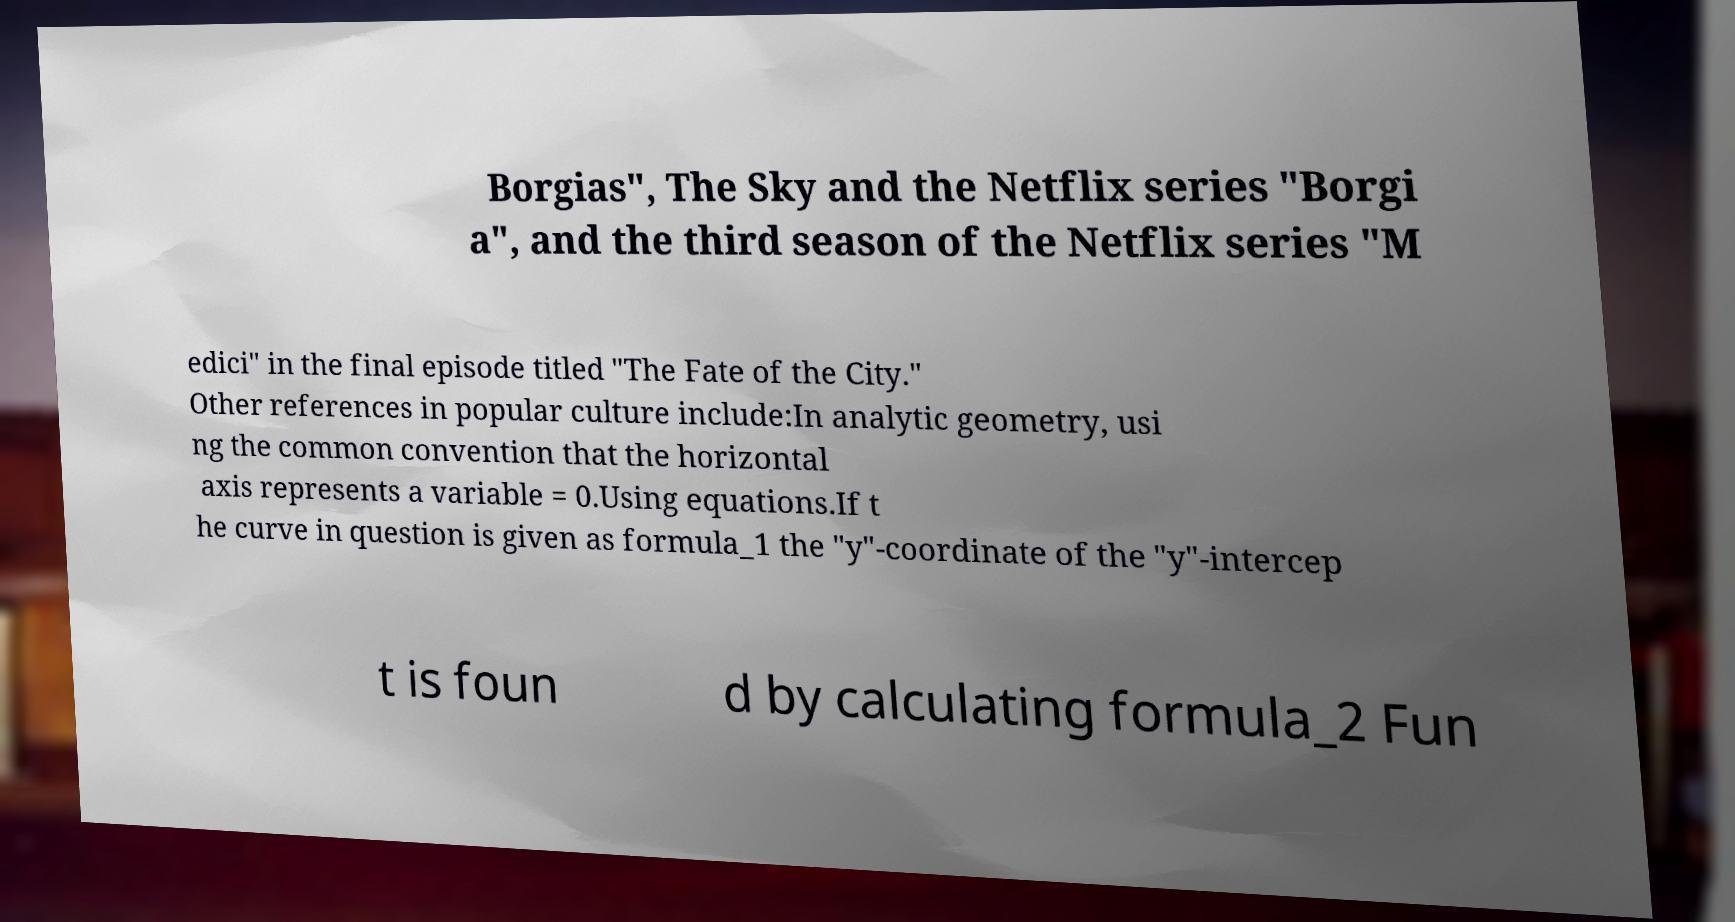For documentation purposes, I need the text within this image transcribed. Could you provide that? Borgias", The Sky and the Netflix series "Borgi a", and the third season of the Netflix series "M edici" in the final episode titled "The Fate of the City." Other references in popular culture include:In analytic geometry, usi ng the common convention that the horizontal axis represents a variable = 0.Using equations.If t he curve in question is given as formula_1 the "y"-coordinate of the "y"-intercep t is foun d by calculating formula_2 Fun 